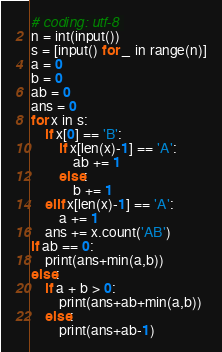<code> <loc_0><loc_0><loc_500><loc_500><_Python_># coding: utf-8 
n = int(input())
s = [input() for _ in range(n)]
a = 0
b = 0
ab = 0
ans = 0
for x in s:
    if x[0] == 'B':
        if x[len(x)-1] == 'A':
            ab += 1
        else:
            b += 1
    elif x[len(x)-1] == 'A':
        a += 1
    ans += x.count('AB')
if ab == 0:
    print(ans+min(a,b))
else:
    if a + b > 0:
        print(ans+ab+min(a,b))
    else:
        print(ans+ab-1)</code> 